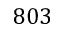<formula> <loc_0><loc_0><loc_500><loc_500>8 0 3</formula> 